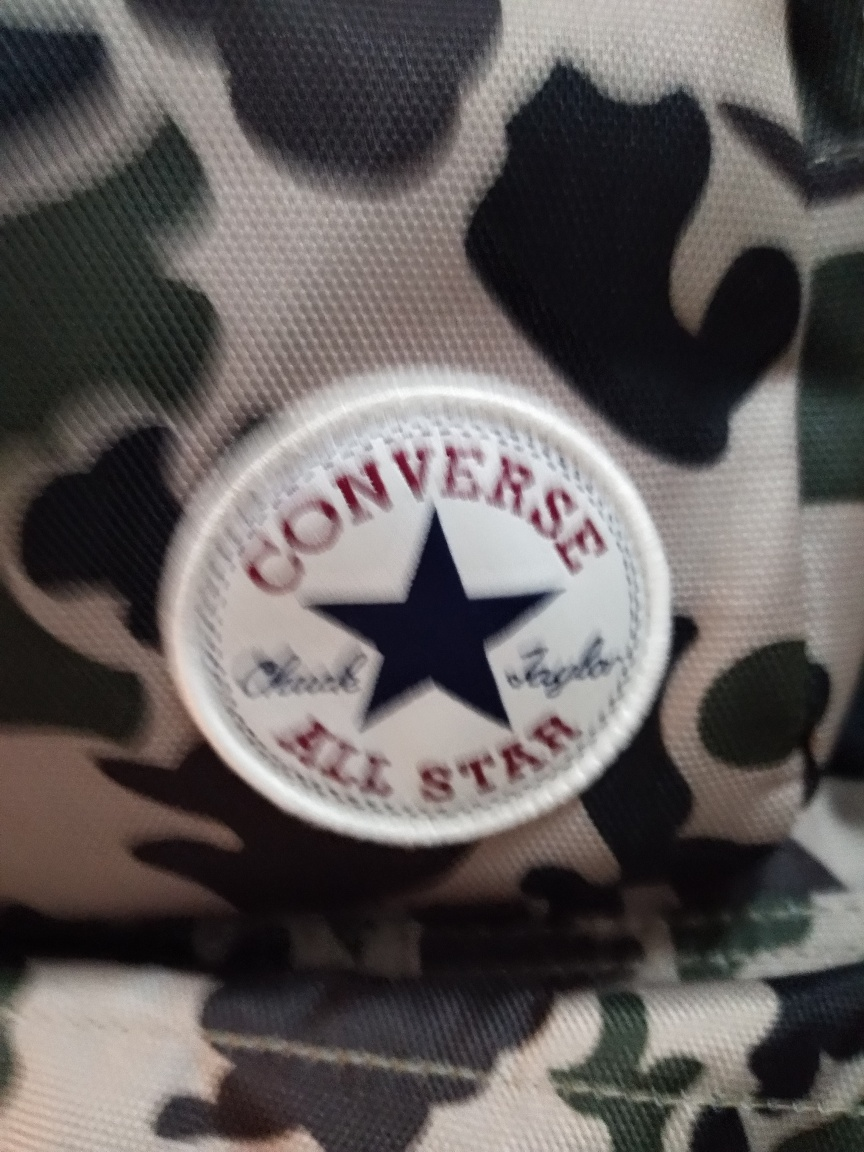Can you describe what's in this image? This image depicts a circular emblem with the logo of a popular footwear brand, known for its signature star-centered design, surrounded by the brand's name and the 'ALL STAR' moniker. Is there anything unique about the background pattern? Yes, the background features a camouflaging pattern with a mix of dark and light patches, which is commonly used in military garments to provide concealment by disrupting visual outlines. 